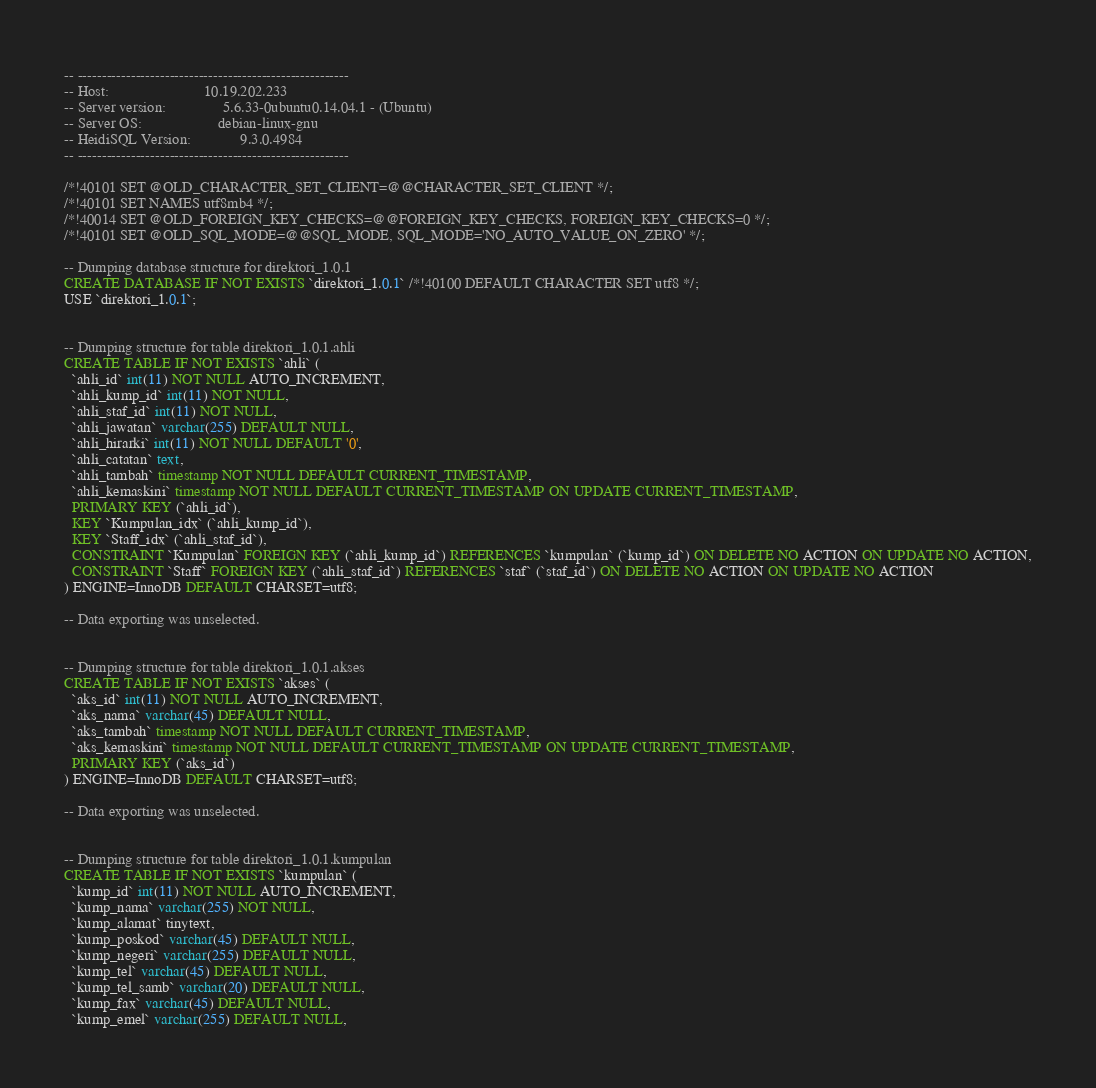<code> <loc_0><loc_0><loc_500><loc_500><_SQL_>-- --------------------------------------------------------
-- Host:                         10.19.202.233
-- Server version:               5.6.33-0ubuntu0.14.04.1 - (Ubuntu)
-- Server OS:                    debian-linux-gnu
-- HeidiSQL Version:             9.3.0.4984
-- --------------------------------------------------------

/*!40101 SET @OLD_CHARACTER_SET_CLIENT=@@CHARACTER_SET_CLIENT */;
/*!40101 SET NAMES utf8mb4 */;
/*!40014 SET @OLD_FOREIGN_KEY_CHECKS=@@FOREIGN_KEY_CHECKS, FOREIGN_KEY_CHECKS=0 */;
/*!40101 SET @OLD_SQL_MODE=@@SQL_MODE, SQL_MODE='NO_AUTO_VALUE_ON_ZERO' */;

-- Dumping database structure for direktori_1.0.1
CREATE DATABASE IF NOT EXISTS `direktori_1.0.1` /*!40100 DEFAULT CHARACTER SET utf8 */;
USE `direktori_1.0.1`;


-- Dumping structure for table direktori_1.0.1.ahli
CREATE TABLE IF NOT EXISTS `ahli` (
  `ahli_id` int(11) NOT NULL AUTO_INCREMENT,
  `ahli_kump_id` int(11) NOT NULL,
  `ahli_staf_id` int(11) NOT NULL,
  `ahli_jawatan` varchar(255) DEFAULT NULL,
  `ahli_hirarki` int(11) NOT NULL DEFAULT '0',
  `ahli_catatan` text,
  `ahli_tambah` timestamp NOT NULL DEFAULT CURRENT_TIMESTAMP,
  `ahli_kemaskini` timestamp NOT NULL DEFAULT CURRENT_TIMESTAMP ON UPDATE CURRENT_TIMESTAMP,
  PRIMARY KEY (`ahli_id`),
  KEY `Kumpulan_idx` (`ahli_kump_id`),
  KEY `Staff_idx` (`ahli_staf_id`),
  CONSTRAINT `Kumpulan` FOREIGN KEY (`ahli_kump_id`) REFERENCES `kumpulan` (`kump_id`) ON DELETE NO ACTION ON UPDATE NO ACTION,
  CONSTRAINT `Staff` FOREIGN KEY (`ahli_staf_id`) REFERENCES `staf` (`staf_id`) ON DELETE NO ACTION ON UPDATE NO ACTION
) ENGINE=InnoDB DEFAULT CHARSET=utf8;

-- Data exporting was unselected.


-- Dumping structure for table direktori_1.0.1.akses
CREATE TABLE IF NOT EXISTS `akses` (
  `aks_id` int(11) NOT NULL AUTO_INCREMENT,
  `aks_nama` varchar(45) DEFAULT NULL,
  `aks_tambah` timestamp NOT NULL DEFAULT CURRENT_TIMESTAMP,
  `aks_kemaskini` timestamp NOT NULL DEFAULT CURRENT_TIMESTAMP ON UPDATE CURRENT_TIMESTAMP,
  PRIMARY KEY (`aks_id`)
) ENGINE=InnoDB DEFAULT CHARSET=utf8;

-- Data exporting was unselected.


-- Dumping structure for table direktori_1.0.1.kumpulan
CREATE TABLE IF NOT EXISTS `kumpulan` (
  `kump_id` int(11) NOT NULL AUTO_INCREMENT,
  `kump_nama` varchar(255) NOT NULL,
  `kump_alamat` tinytext,
  `kump_poskod` varchar(45) DEFAULT NULL,
  `kump_negeri` varchar(255) DEFAULT NULL,
  `kump_tel` varchar(45) DEFAULT NULL,
  `kump_tel_samb` varchar(20) DEFAULT NULL,
  `kump_fax` varchar(45) DEFAULT NULL,
  `kump_emel` varchar(255) DEFAULT NULL,</code> 